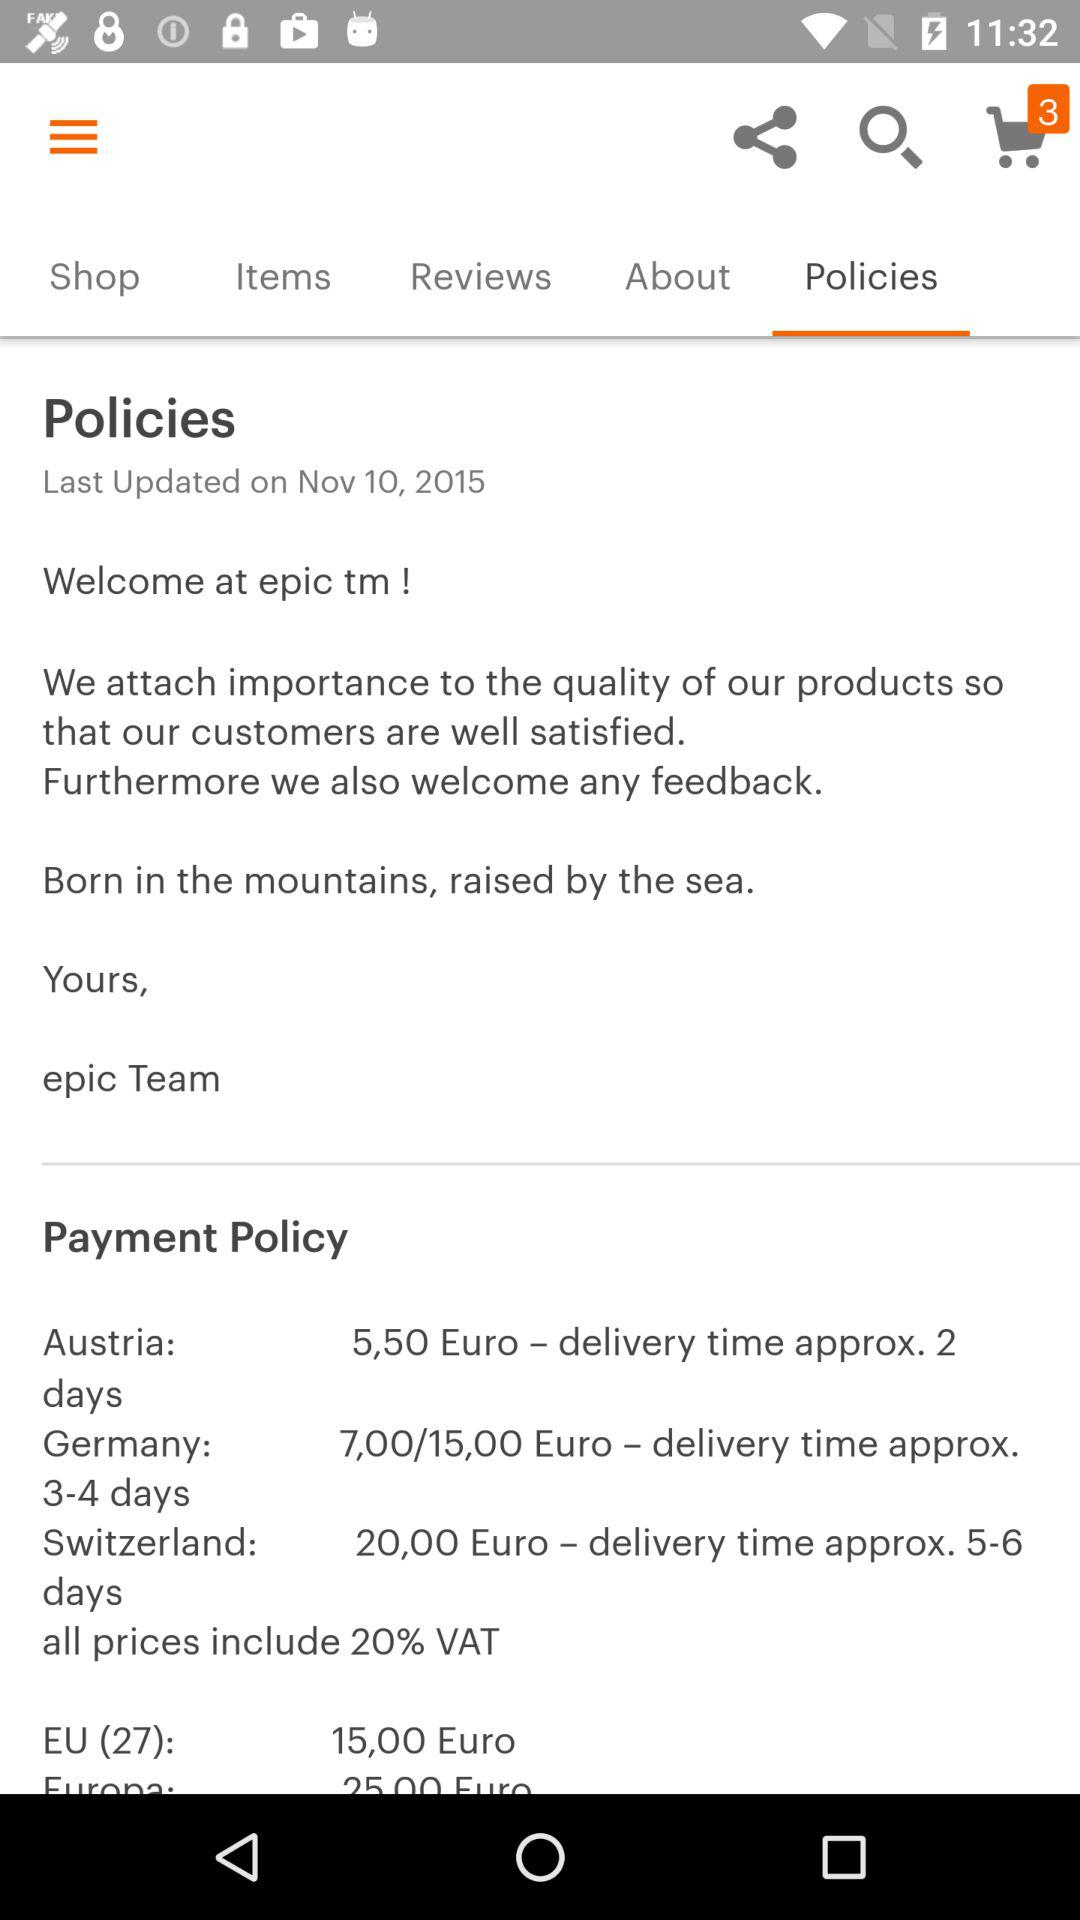What is the price mentioned for Austria? The Price is 5,50 Euro. 